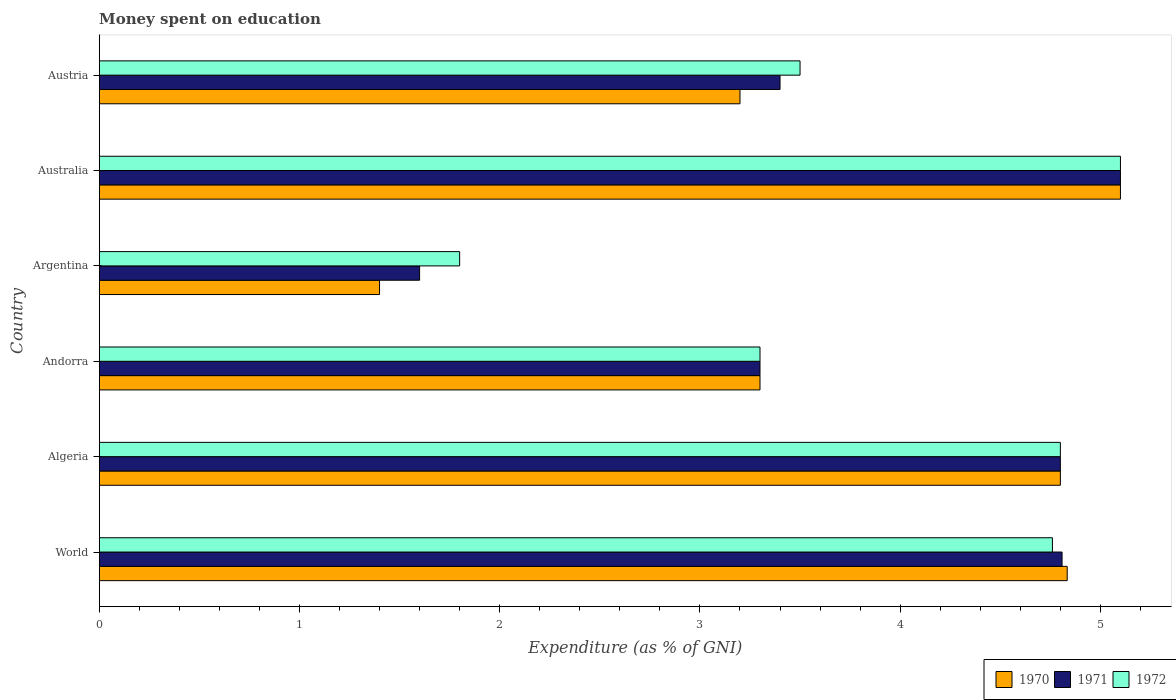How many different coloured bars are there?
Make the answer very short. 3. How many groups of bars are there?
Offer a terse response. 6. What is the label of the 5th group of bars from the top?
Provide a short and direct response. Algeria. In which country was the amount of money spent on education in 1972 minimum?
Give a very brief answer. Argentina. What is the total amount of money spent on education in 1970 in the graph?
Your response must be concise. 22.63. What is the difference between the amount of money spent on education in 1972 in Algeria and the amount of money spent on education in 1971 in Australia?
Your answer should be compact. -0.3. What is the average amount of money spent on education in 1972 per country?
Ensure brevity in your answer.  3.88. What is the difference between the amount of money spent on education in 1971 and amount of money spent on education in 1972 in World?
Your response must be concise. 0.05. In how many countries, is the amount of money spent on education in 1970 greater than 4.8 %?
Provide a succinct answer. 2. What is the ratio of the amount of money spent on education in 1970 in Argentina to that in Austria?
Make the answer very short. 0.44. What is the difference between the highest and the second highest amount of money spent on education in 1970?
Your answer should be very brief. 0.27. What is the difference between the highest and the lowest amount of money spent on education in 1972?
Offer a terse response. 3.3. In how many countries, is the amount of money spent on education in 1971 greater than the average amount of money spent on education in 1971 taken over all countries?
Ensure brevity in your answer.  3. What does the 1st bar from the top in World represents?
Make the answer very short. 1972. Is it the case that in every country, the sum of the amount of money spent on education in 1972 and amount of money spent on education in 1970 is greater than the amount of money spent on education in 1971?
Offer a very short reply. Yes. What is the difference between two consecutive major ticks on the X-axis?
Ensure brevity in your answer.  1. Are the values on the major ticks of X-axis written in scientific E-notation?
Provide a succinct answer. No. How many legend labels are there?
Your answer should be very brief. 3. How are the legend labels stacked?
Make the answer very short. Horizontal. What is the title of the graph?
Offer a terse response. Money spent on education. Does "1983" appear as one of the legend labels in the graph?
Offer a very short reply. No. What is the label or title of the X-axis?
Make the answer very short. Expenditure (as % of GNI). What is the label or title of the Y-axis?
Your response must be concise. Country. What is the Expenditure (as % of GNI) of 1970 in World?
Offer a very short reply. 4.83. What is the Expenditure (as % of GNI) in 1971 in World?
Provide a succinct answer. 4.81. What is the Expenditure (as % of GNI) of 1972 in World?
Your answer should be compact. 4.76. What is the Expenditure (as % of GNI) in 1971 in Algeria?
Your response must be concise. 4.8. What is the Expenditure (as % of GNI) in 1972 in Algeria?
Your answer should be compact. 4.8. What is the Expenditure (as % of GNI) in 1971 in Andorra?
Keep it short and to the point. 3.3. What is the Expenditure (as % of GNI) of 1970 in Argentina?
Give a very brief answer. 1.4. What is the Expenditure (as % of GNI) in 1971 in Argentina?
Make the answer very short. 1.6. What is the Expenditure (as % of GNI) in 1972 in Argentina?
Keep it short and to the point. 1.8. What is the Expenditure (as % of GNI) of 1971 in Australia?
Ensure brevity in your answer.  5.1. What is the Expenditure (as % of GNI) of 1971 in Austria?
Make the answer very short. 3.4. Across all countries, what is the maximum Expenditure (as % of GNI) in 1970?
Keep it short and to the point. 5.1. Across all countries, what is the maximum Expenditure (as % of GNI) of 1971?
Your answer should be very brief. 5.1. Across all countries, what is the minimum Expenditure (as % of GNI) in 1970?
Provide a succinct answer. 1.4. Across all countries, what is the minimum Expenditure (as % of GNI) of 1971?
Ensure brevity in your answer.  1.6. What is the total Expenditure (as % of GNI) of 1970 in the graph?
Provide a succinct answer. 22.63. What is the total Expenditure (as % of GNI) in 1971 in the graph?
Keep it short and to the point. 23.01. What is the total Expenditure (as % of GNI) in 1972 in the graph?
Make the answer very short. 23.26. What is the difference between the Expenditure (as % of GNI) of 1970 in World and that in Algeria?
Your answer should be very brief. 0.03. What is the difference between the Expenditure (as % of GNI) of 1971 in World and that in Algeria?
Provide a succinct answer. 0.01. What is the difference between the Expenditure (as % of GNI) in 1972 in World and that in Algeria?
Provide a short and direct response. -0.04. What is the difference between the Expenditure (as % of GNI) of 1970 in World and that in Andorra?
Your answer should be compact. 1.53. What is the difference between the Expenditure (as % of GNI) of 1971 in World and that in Andorra?
Provide a succinct answer. 1.51. What is the difference between the Expenditure (as % of GNI) of 1972 in World and that in Andorra?
Keep it short and to the point. 1.46. What is the difference between the Expenditure (as % of GNI) in 1970 in World and that in Argentina?
Your answer should be compact. 3.43. What is the difference between the Expenditure (as % of GNI) in 1971 in World and that in Argentina?
Keep it short and to the point. 3.21. What is the difference between the Expenditure (as % of GNI) in 1972 in World and that in Argentina?
Your answer should be very brief. 2.96. What is the difference between the Expenditure (as % of GNI) of 1970 in World and that in Australia?
Ensure brevity in your answer.  -0.27. What is the difference between the Expenditure (as % of GNI) in 1971 in World and that in Australia?
Give a very brief answer. -0.29. What is the difference between the Expenditure (as % of GNI) of 1972 in World and that in Australia?
Make the answer very short. -0.34. What is the difference between the Expenditure (as % of GNI) of 1970 in World and that in Austria?
Make the answer very short. 1.63. What is the difference between the Expenditure (as % of GNI) of 1971 in World and that in Austria?
Give a very brief answer. 1.41. What is the difference between the Expenditure (as % of GNI) of 1972 in World and that in Austria?
Provide a short and direct response. 1.26. What is the difference between the Expenditure (as % of GNI) of 1970 in Algeria and that in Australia?
Offer a very short reply. -0.3. What is the difference between the Expenditure (as % of GNI) in 1972 in Andorra and that in Argentina?
Your answer should be very brief. 1.5. What is the difference between the Expenditure (as % of GNI) in 1970 in Andorra and that in Australia?
Make the answer very short. -1.8. What is the difference between the Expenditure (as % of GNI) in 1971 in Andorra and that in Australia?
Make the answer very short. -1.8. What is the difference between the Expenditure (as % of GNI) in 1971 in Andorra and that in Austria?
Offer a very short reply. -0.1. What is the difference between the Expenditure (as % of GNI) of 1970 in Argentina and that in Australia?
Offer a very short reply. -3.7. What is the difference between the Expenditure (as % of GNI) in 1972 in Argentina and that in Australia?
Your response must be concise. -3.3. What is the difference between the Expenditure (as % of GNI) of 1970 in Argentina and that in Austria?
Your response must be concise. -1.8. What is the difference between the Expenditure (as % of GNI) in 1970 in Australia and that in Austria?
Your answer should be very brief. 1.9. What is the difference between the Expenditure (as % of GNI) in 1972 in Australia and that in Austria?
Your answer should be very brief. 1.6. What is the difference between the Expenditure (as % of GNI) of 1970 in World and the Expenditure (as % of GNI) of 1971 in Algeria?
Your response must be concise. 0.03. What is the difference between the Expenditure (as % of GNI) in 1970 in World and the Expenditure (as % of GNI) in 1972 in Algeria?
Provide a succinct answer. 0.03. What is the difference between the Expenditure (as % of GNI) of 1971 in World and the Expenditure (as % of GNI) of 1972 in Algeria?
Your answer should be very brief. 0.01. What is the difference between the Expenditure (as % of GNI) of 1970 in World and the Expenditure (as % of GNI) of 1971 in Andorra?
Give a very brief answer. 1.53. What is the difference between the Expenditure (as % of GNI) in 1970 in World and the Expenditure (as % of GNI) in 1972 in Andorra?
Offer a terse response. 1.53. What is the difference between the Expenditure (as % of GNI) in 1971 in World and the Expenditure (as % of GNI) in 1972 in Andorra?
Provide a succinct answer. 1.51. What is the difference between the Expenditure (as % of GNI) of 1970 in World and the Expenditure (as % of GNI) of 1971 in Argentina?
Give a very brief answer. 3.23. What is the difference between the Expenditure (as % of GNI) of 1970 in World and the Expenditure (as % of GNI) of 1972 in Argentina?
Your answer should be compact. 3.03. What is the difference between the Expenditure (as % of GNI) in 1971 in World and the Expenditure (as % of GNI) in 1972 in Argentina?
Provide a succinct answer. 3.01. What is the difference between the Expenditure (as % of GNI) of 1970 in World and the Expenditure (as % of GNI) of 1971 in Australia?
Provide a short and direct response. -0.27. What is the difference between the Expenditure (as % of GNI) of 1970 in World and the Expenditure (as % of GNI) of 1972 in Australia?
Offer a terse response. -0.27. What is the difference between the Expenditure (as % of GNI) of 1971 in World and the Expenditure (as % of GNI) of 1972 in Australia?
Make the answer very short. -0.29. What is the difference between the Expenditure (as % of GNI) in 1970 in World and the Expenditure (as % of GNI) in 1971 in Austria?
Keep it short and to the point. 1.43. What is the difference between the Expenditure (as % of GNI) in 1970 in World and the Expenditure (as % of GNI) in 1972 in Austria?
Give a very brief answer. 1.33. What is the difference between the Expenditure (as % of GNI) of 1971 in World and the Expenditure (as % of GNI) of 1972 in Austria?
Offer a terse response. 1.31. What is the difference between the Expenditure (as % of GNI) of 1970 in Algeria and the Expenditure (as % of GNI) of 1972 in Andorra?
Your answer should be very brief. 1.5. What is the difference between the Expenditure (as % of GNI) of 1971 in Algeria and the Expenditure (as % of GNI) of 1972 in Andorra?
Your response must be concise. 1.5. What is the difference between the Expenditure (as % of GNI) in 1970 in Algeria and the Expenditure (as % of GNI) in 1972 in Argentina?
Provide a succinct answer. 3. What is the difference between the Expenditure (as % of GNI) of 1970 in Algeria and the Expenditure (as % of GNI) of 1971 in Australia?
Provide a short and direct response. -0.3. What is the difference between the Expenditure (as % of GNI) in 1970 in Algeria and the Expenditure (as % of GNI) in 1971 in Austria?
Provide a succinct answer. 1.4. What is the difference between the Expenditure (as % of GNI) of 1970 in Algeria and the Expenditure (as % of GNI) of 1972 in Austria?
Make the answer very short. 1.3. What is the difference between the Expenditure (as % of GNI) of 1971 in Algeria and the Expenditure (as % of GNI) of 1972 in Austria?
Ensure brevity in your answer.  1.3. What is the difference between the Expenditure (as % of GNI) in 1970 in Andorra and the Expenditure (as % of GNI) in 1971 in Argentina?
Give a very brief answer. 1.7. What is the difference between the Expenditure (as % of GNI) in 1970 in Andorra and the Expenditure (as % of GNI) in 1972 in Argentina?
Offer a very short reply. 1.5. What is the difference between the Expenditure (as % of GNI) in 1971 in Andorra and the Expenditure (as % of GNI) in 1972 in Argentina?
Your response must be concise. 1.5. What is the difference between the Expenditure (as % of GNI) in 1970 in Andorra and the Expenditure (as % of GNI) in 1971 in Australia?
Make the answer very short. -1.8. What is the difference between the Expenditure (as % of GNI) of 1970 in Andorra and the Expenditure (as % of GNI) of 1972 in Australia?
Provide a short and direct response. -1.8. What is the difference between the Expenditure (as % of GNI) in 1970 in Andorra and the Expenditure (as % of GNI) in 1971 in Austria?
Make the answer very short. -0.1. What is the difference between the Expenditure (as % of GNI) of 1971 in Andorra and the Expenditure (as % of GNI) of 1972 in Austria?
Provide a succinct answer. -0.2. What is the difference between the Expenditure (as % of GNI) of 1970 in Argentina and the Expenditure (as % of GNI) of 1972 in Australia?
Provide a short and direct response. -3.7. What is the difference between the Expenditure (as % of GNI) in 1971 in Argentina and the Expenditure (as % of GNI) in 1972 in Austria?
Your response must be concise. -1.9. What is the difference between the Expenditure (as % of GNI) in 1970 in Australia and the Expenditure (as % of GNI) in 1971 in Austria?
Provide a short and direct response. 1.7. What is the difference between the Expenditure (as % of GNI) of 1970 in Australia and the Expenditure (as % of GNI) of 1972 in Austria?
Your answer should be compact. 1.6. What is the average Expenditure (as % of GNI) in 1970 per country?
Your answer should be very brief. 3.77. What is the average Expenditure (as % of GNI) in 1971 per country?
Your response must be concise. 3.83. What is the average Expenditure (as % of GNI) in 1972 per country?
Offer a very short reply. 3.88. What is the difference between the Expenditure (as % of GNI) in 1970 and Expenditure (as % of GNI) in 1971 in World?
Your response must be concise. 0.03. What is the difference between the Expenditure (as % of GNI) of 1970 and Expenditure (as % of GNI) of 1972 in World?
Provide a succinct answer. 0.07. What is the difference between the Expenditure (as % of GNI) of 1971 and Expenditure (as % of GNI) of 1972 in World?
Your answer should be compact. 0.05. What is the difference between the Expenditure (as % of GNI) in 1970 and Expenditure (as % of GNI) in 1972 in Algeria?
Give a very brief answer. 0. What is the difference between the Expenditure (as % of GNI) in 1970 and Expenditure (as % of GNI) in 1971 in Andorra?
Provide a succinct answer. 0. What is the difference between the Expenditure (as % of GNI) of 1970 and Expenditure (as % of GNI) of 1972 in Andorra?
Your answer should be compact. 0. What is the difference between the Expenditure (as % of GNI) in 1970 and Expenditure (as % of GNI) in 1971 in Austria?
Make the answer very short. -0.2. What is the difference between the Expenditure (as % of GNI) in 1970 and Expenditure (as % of GNI) in 1972 in Austria?
Your response must be concise. -0.3. What is the difference between the Expenditure (as % of GNI) in 1971 and Expenditure (as % of GNI) in 1972 in Austria?
Provide a short and direct response. -0.1. What is the ratio of the Expenditure (as % of GNI) of 1970 in World to that in Algeria?
Offer a terse response. 1.01. What is the ratio of the Expenditure (as % of GNI) of 1971 in World to that in Algeria?
Your answer should be compact. 1. What is the ratio of the Expenditure (as % of GNI) in 1972 in World to that in Algeria?
Your response must be concise. 0.99. What is the ratio of the Expenditure (as % of GNI) of 1970 in World to that in Andorra?
Give a very brief answer. 1.46. What is the ratio of the Expenditure (as % of GNI) in 1971 in World to that in Andorra?
Offer a very short reply. 1.46. What is the ratio of the Expenditure (as % of GNI) in 1972 in World to that in Andorra?
Provide a short and direct response. 1.44. What is the ratio of the Expenditure (as % of GNI) of 1970 in World to that in Argentina?
Offer a very short reply. 3.45. What is the ratio of the Expenditure (as % of GNI) in 1971 in World to that in Argentina?
Offer a very short reply. 3.01. What is the ratio of the Expenditure (as % of GNI) of 1972 in World to that in Argentina?
Ensure brevity in your answer.  2.64. What is the ratio of the Expenditure (as % of GNI) in 1970 in World to that in Australia?
Provide a succinct answer. 0.95. What is the ratio of the Expenditure (as % of GNI) in 1971 in World to that in Australia?
Keep it short and to the point. 0.94. What is the ratio of the Expenditure (as % of GNI) of 1972 in World to that in Australia?
Make the answer very short. 0.93. What is the ratio of the Expenditure (as % of GNI) in 1970 in World to that in Austria?
Your answer should be compact. 1.51. What is the ratio of the Expenditure (as % of GNI) of 1971 in World to that in Austria?
Offer a very short reply. 1.41. What is the ratio of the Expenditure (as % of GNI) of 1972 in World to that in Austria?
Ensure brevity in your answer.  1.36. What is the ratio of the Expenditure (as % of GNI) in 1970 in Algeria to that in Andorra?
Make the answer very short. 1.45. What is the ratio of the Expenditure (as % of GNI) of 1971 in Algeria to that in Andorra?
Offer a very short reply. 1.45. What is the ratio of the Expenditure (as % of GNI) in 1972 in Algeria to that in Andorra?
Give a very brief answer. 1.45. What is the ratio of the Expenditure (as % of GNI) of 1970 in Algeria to that in Argentina?
Your answer should be very brief. 3.43. What is the ratio of the Expenditure (as % of GNI) in 1972 in Algeria to that in Argentina?
Give a very brief answer. 2.67. What is the ratio of the Expenditure (as % of GNI) in 1971 in Algeria to that in Australia?
Provide a succinct answer. 0.94. What is the ratio of the Expenditure (as % of GNI) of 1971 in Algeria to that in Austria?
Your answer should be very brief. 1.41. What is the ratio of the Expenditure (as % of GNI) in 1972 in Algeria to that in Austria?
Your answer should be compact. 1.37. What is the ratio of the Expenditure (as % of GNI) in 1970 in Andorra to that in Argentina?
Keep it short and to the point. 2.36. What is the ratio of the Expenditure (as % of GNI) in 1971 in Andorra to that in Argentina?
Your answer should be compact. 2.06. What is the ratio of the Expenditure (as % of GNI) in 1972 in Andorra to that in Argentina?
Provide a short and direct response. 1.83. What is the ratio of the Expenditure (as % of GNI) in 1970 in Andorra to that in Australia?
Give a very brief answer. 0.65. What is the ratio of the Expenditure (as % of GNI) of 1971 in Andorra to that in Australia?
Your response must be concise. 0.65. What is the ratio of the Expenditure (as % of GNI) of 1972 in Andorra to that in Australia?
Your answer should be very brief. 0.65. What is the ratio of the Expenditure (as % of GNI) of 1970 in Andorra to that in Austria?
Make the answer very short. 1.03. What is the ratio of the Expenditure (as % of GNI) in 1971 in Andorra to that in Austria?
Ensure brevity in your answer.  0.97. What is the ratio of the Expenditure (as % of GNI) of 1972 in Andorra to that in Austria?
Your answer should be very brief. 0.94. What is the ratio of the Expenditure (as % of GNI) of 1970 in Argentina to that in Australia?
Provide a succinct answer. 0.27. What is the ratio of the Expenditure (as % of GNI) in 1971 in Argentina to that in Australia?
Your answer should be compact. 0.31. What is the ratio of the Expenditure (as % of GNI) of 1972 in Argentina to that in Australia?
Ensure brevity in your answer.  0.35. What is the ratio of the Expenditure (as % of GNI) of 1970 in Argentina to that in Austria?
Give a very brief answer. 0.44. What is the ratio of the Expenditure (as % of GNI) in 1971 in Argentina to that in Austria?
Your answer should be very brief. 0.47. What is the ratio of the Expenditure (as % of GNI) of 1972 in Argentina to that in Austria?
Provide a succinct answer. 0.51. What is the ratio of the Expenditure (as % of GNI) of 1970 in Australia to that in Austria?
Offer a terse response. 1.59. What is the ratio of the Expenditure (as % of GNI) of 1972 in Australia to that in Austria?
Keep it short and to the point. 1.46. What is the difference between the highest and the second highest Expenditure (as % of GNI) in 1970?
Keep it short and to the point. 0.27. What is the difference between the highest and the second highest Expenditure (as % of GNI) in 1971?
Your answer should be compact. 0.29. What is the difference between the highest and the second highest Expenditure (as % of GNI) of 1972?
Ensure brevity in your answer.  0.3. 